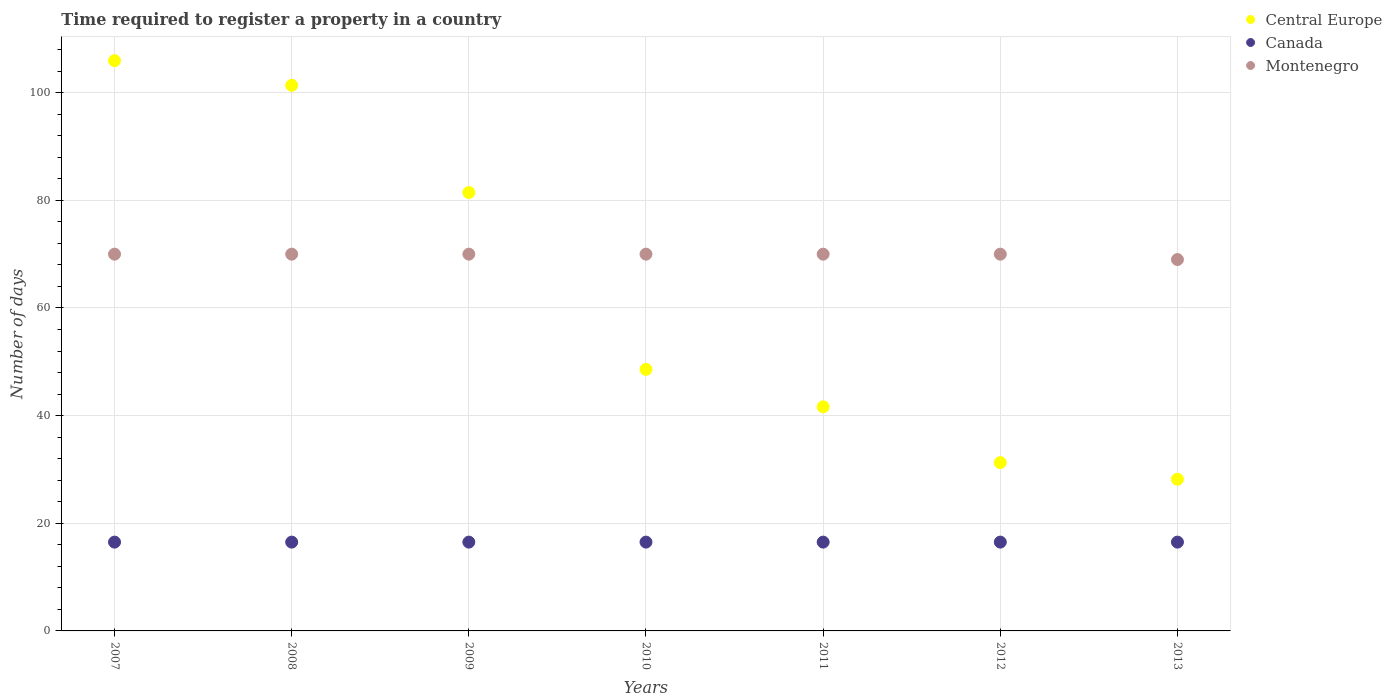How many different coloured dotlines are there?
Your response must be concise. 3. What is the number of days required to register a property in Canada in 2007?
Provide a short and direct response. 16.5. Across all years, what is the maximum number of days required to register a property in Central Europe?
Make the answer very short. 105.95. Across all years, what is the minimum number of days required to register a property in Montenegro?
Provide a succinct answer. 69. In which year was the number of days required to register a property in Montenegro maximum?
Make the answer very short. 2007. In which year was the number of days required to register a property in Canada minimum?
Provide a succinct answer. 2007. What is the total number of days required to register a property in Central Europe in the graph?
Provide a short and direct response. 438.45. What is the difference between the number of days required to register a property in Canada in 2008 and that in 2012?
Keep it short and to the point. 0. What is the difference between the number of days required to register a property in Canada in 2013 and the number of days required to register a property in Central Europe in 2009?
Provide a succinct answer. -64.95. What is the average number of days required to register a property in Montenegro per year?
Your answer should be compact. 69.86. In the year 2007, what is the difference between the number of days required to register a property in Central Europe and number of days required to register a property in Canada?
Your response must be concise. 89.45. In how many years, is the number of days required to register a property in Central Europe greater than 56 days?
Give a very brief answer. 3. What is the ratio of the number of days required to register a property in Montenegro in 2007 to that in 2011?
Your answer should be compact. 1. What is the difference between the highest and the lowest number of days required to register a property in Canada?
Your answer should be very brief. 0. In how many years, is the number of days required to register a property in Canada greater than the average number of days required to register a property in Canada taken over all years?
Provide a succinct answer. 0. Is the sum of the number of days required to register a property in Montenegro in 2011 and 2013 greater than the maximum number of days required to register a property in Central Europe across all years?
Give a very brief answer. Yes. Is it the case that in every year, the sum of the number of days required to register a property in Central Europe and number of days required to register a property in Montenegro  is greater than the number of days required to register a property in Canada?
Give a very brief answer. Yes. Does the number of days required to register a property in Canada monotonically increase over the years?
Offer a very short reply. No. Is the number of days required to register a property in Montenegro strictly greater than the number of days required to register a property in Central Europe over the years?
Ensure brevity in your answer.  No. How many dotlines are there?
Your answer should be compact. 3. How many years are there in the graph?
Keep it short and to the point. 7. What is the difference between two consecutive major ticks on the Y-axis?
Provide a succinct answer. 20. Are the values on the major ticks of Y-axis written in scientific E-notation?
Keep it short and to the point. No. Does the graph contain grids?
Provide a short and direct response. Yes. Where does the legend appear in the graph?
Make the answer very short. Top right. How are the legend labels stacked?
Give a very brief answer. Vertical. What is the title of the graph?
Your answer should be very brief. Time required to register a property in a country. What is the label or title of the Y-axis?
Provide a short and direct response. Number of days. What is the Number of days in Central Europe in 2007?
Your answer should be compact. 105.95. What is the Number of days of Canada in 2007?
Give a very brief answer. 16.5. What is the Number of days in Montenegro in 2007?
Your response must be concise. 70. What is the Number of days in Central Europe in 2008?
Your answer should be very brief. 101.36. What is the Number of days of Central Europe in 2009?
Your answer should be compact. 81.45. What is the Number of days in Canada in 2009?
Your answer should be compact. 16.5. What is the Number of days of Central Europe in 2010?
Provide a short and direct response. 48.59. What is the Number of days of Canada in 2010?
Provide a succinct answer. 16.5. What is the Number of days in Montenegro in 2010?
Your answer should be very brief. 70. What is the Number of days of Central Europe in 2011?
Give a very brief answer. 41.64. What is the Number of days in Canada in 2011?
Provide a succinct answer. 16.5. What is the Number of days in Montenegro in 2011?
Offer a terse response. 70. What is the Number of days of Central Europe in 2012?
Your response must be concise. 31.27. What is the Number of days of Canada in 2012?
Your answer should be compact. 16.5. What is the Number of days in Montenegro in 2012?
Your response must be concise. 70. What is the Number of days of Central Europe in 2013?
Keep it short and to the point. 28.18. What is the Number of days in Canada in 2013?
Your answer should be compact. 16.5. Across all years, what is the maximum Number of days of Central Europe?
Ensure brevity in your answer.  105.95. Across all years, what is the minimum Number of days in Central Europe?
Offer a terse response. 28.18. Across all years, what is the minimum Number of days of Montenegro?
Offer a very short reply. 69. What is the total Number of days in Central Europe in the graph?
Make the answer very short. 438.45. What is the total Number of days of Canada in the graph?
Provide a short and direct response. 115.5. What is the total Number of days of Montenegro in the graph?
Provide a succinct answer. 489. What is the difference between the Number of days in Central Europe in 2007 and that in 2008?
Keep it short and to the point. 4.59. What is the difference between the Number of days in Canada in 2007 and that in 2008?
Your response must be concise. 0. What is the difference between the Number of days of Central Europe in 2007 and that in 2009?
Offer a very short reply. 24.5. What is the difference between the Number of days of Montenegro in 2007 and that in 2009?
Give a very brief answer. 0. What is the difference between the Number of days of Central Europe in 2007 and that in 2010?
Make the answer very short. 57.36. What is the difference between the Number of days of Canada in 2007 and that in 2010?
Ensure brevity in your answer.  0. What is the difference between the Number of days in Montenegro in 2007 and that in 2010?
Provide a short and direct response. 0. What is the difference between the Number of days in Central Europe in 2007 and that in 2011?
Provide a succinct answer. 64.32. What is the difference between the Number of days of Montenegro in 2007 and that in 2011?
Your answer should be compact. 0. What is the difference between the Number of days in Central Europe in 2007 and that in 2012?
Your answer should be very brief. 74.68. What is the difference between the Number of days of Canada in 2007 and that in 2012?
Give a very brief answer. 0. What is the difference between the Number of days in Central Europe in 2007 and that in 2013?
Keep it short and to the point. 77.77. What is the difference between the Number of days of Canada in 2007 and that in 2013?
Give a very brief answer. 0. What is the difference between the Number of days in Montenegro in 2007 and that in 2013?
Provide a succinct answer. 1. What is the difference between the Number of days in Central Europe in 2008 and that in 2009?
Offer a very short reply. 19.91. What is the difference between the Number of days of Montenegro in 2008 and that in 2009?
Your answer should be very brief. 0. What is the difference between the Number of days in Central Europe in 2008 and that in 2010?
Offer a very short reply. 52.77. What is the difference between the Number of days in Central Europe in 2008 and that in 2011?
Make the answer very short. 59.73. What is the difference between the Number of days in Montenegro in 2008 and that in 2011?
Keep it short and to the point. 0. What is the difference between the Number of days of Central Europe in 2008 and that in 2012?
Provide a succinct answer. 70.09. What is the difference between the Number of days in Central Europe in 2008 and that in 2013?
Provide a succinct answer. 73.18. What is the difference between the Number of days in Canada in 2008 and that in 2013?
Keep it short and to the point. 0. What is the difference between the Number of days in Central Europe in 2009 and that in 2010?
Keep it short and to the point. 32.86. What is the difference between the Number of days of Canada in 2009 and that in 2010?
Offer a terse response. 0. What is the difference between the Number of days of Montenegro in 2009 and that in 2010?
Offer a very short reply. 0. What is the difference between the Number of days of Central Europe in 2009 and that in 2011?
Make the answer very short. 39.82. What is the difference between the Number of days in Canada in 2009 and that in 2011?
Your response must be concise. 0. What is the difference between the Number of days of Montenegro in 2009 and that in 2011?
Offer a terse response. 0. What is the difference between the Number of days of Central Europe in 2009 and that in 2012?
Offer a very short reply. 50.18. What is the difference between the Number of days of Montenegro in 2009 and that in 2012?
Your answer should be compact. 0. What is the difference between the Number of days of Central Europe in 2009 and that in 2013?
Keep it short and to the point. 53.27. What is the difference between the Number of days of Canada in 2009 and that in 2013?
Ensure brevity in your answer.  0. What is the difference between the Number of days in Montenegro in 2009 and that in 2013?
Keep it short and to the point. 1. What is the difference between the Number of days in Central Europe in 2010 and that in 2011?
Provide a short and direct response. 6.95. What is the difference between the Number of days in Central Europe in 2010 and that in 2012?
Ensure brevity in your answer.  17.32. What is the difference between the Number of days in Central Europe in 2010 and that in 2013?
Offer a terse response. 20.41. What is the difference between the Number of days in Central Europe in 2011 and that in 2012?
Provide a short and direct response. 10.36. What is the difference between the Number of days in Canada in 2011 and that in 2012?
Ensure brevity in your answer.  0. What is the difference between the Number of days in Montenegro in 2011 and that in 2012?
Offer a very short reply. 0. What is the difference between the Number of days in Central Europe in 2011 and that in 2013?
Offer a terse response. 13.45. What is the difference between the Number of days in Canada in 2011 and that in 2013?
Make the answer very short. 0. What is the difference between the Number of days of Montenegro in 2011 and that in 2013?
Your response must be concise. 1. What is the difference between the Number of days of Central Europe in 2012 and that in 2013?
Keep it short and to the point. 3.09. What is the difference between the Number of days of Canada in 2012 and that in 2013?
Give a very brief answer. 0. What is the difference between the Number of days of Central Europe in 2007 and the Number of days of Canada in 2008?
Give a very brief answer. 89.45. What is the difference between the Number of days of Central Europe in 2007 and the Number of days of Montenegro in 2008?
Ensure brevity in your answer.  35.95. What is the difference between the Number of days of Canada in 2007 and the Number of days of Montenegro in 2008?
Your response must be concise. -53.5. What is the difference between the Number of days of Central Europe in 2007 and the Number of days of Canada in 2009?
Your answer should be very brief. 89.45. What is the difference between the Number of days in Central Europe in 2007 and the Number of days in Montenegro in 2009?
Ensure brevity in your answer.  35.95. What is the difference between the Number of days in Canada in 2007 and the Number of days in Montenegro in 2009?
Keep it short and to the point. -53.5. What is the difference between the Number of days in Central Europe in 2007 and the Number of days in Canada in 2010?
Provide a short and direct response. 89.45. What is the difference between the Number of days of Central Europe in 2007 and the Number of days of Montenegro in 2010?
Offer a very short reply. 35.95. What is the difference between the Number of days in Canada in 2007 and the Number of days in Montenegro in 2010?
Keep it short and to the point. -53.5. What is the difference between the Number of days of Central Europe in 2007 and the Number of days of Canada in 2011?
Provide a succinct answer. 89.45. What is the difference between the Number of days of Central Europe in 2007 and the Number of days of Montenegro in 2011?
Give a very brief answer. 35.95. What is the difference between the Number of days of Canada in 2007 and the Number of days of Montenegro in 2011?
Provide a succinct answer. -53.5. What is the difference between the Number of days in Central Europe in 2007 and the Number of days in Canada in 2012?
Your answer should be very brief. 89.45. What is the difference between the Number of days of Central Europe in 2007 and the Number of days of Montenegro in 2012?
Your response must be concise. 35.95. What is the difference between the Number of days of Canada in 2007 and the Number of days of Montenegro in 2012?
Offer a very short reply. -53.5. What is the difference between the Number of days of Central Europe in 2007 and the Number of days of Canada in 2013?
Provide a short and direct response. 89.45. What is the difference between the Number of days in Central Europe in 2007 and the Number of days in Montenegro in 2013?
Ensure brevity in your answer.  36.95. What is the difference between the Number of days of Canada in 2007 and the Number of days of Montenegro in 2013?
Provide a succinct answer. -52.5. What is the difference between the Number of days of Central Europe in 2008 and the Number of days of Canada in 2009?
Make the answer very short. 84.86. What is the difference between the Number of days of Central Europe in 2008 and the Number of days of Montenegro in 2009?
Offer a terse response. 31.36. What is the difference between the Number of days of Canada in 2008 and the Number of days of Montenegro in 2009?
Ensure brevity in your answer.  -53.5. What is the difference between the Number of days of Central Europe in 2008 and the Number of days of Canada in 2010?
Ensure brevity in your answer.  84.86. What is the difference between the Number of days of Central Europe in 2008 and the Number of days of Montenegro in 2010?
Provide a succinct answer. 31.36. What is the difference between the Number of days in Canada in 2008 and the Number of days in Montenegro in 2010?
Make the answer very short. -53.5. What is the difference between the Number of days in Central Europe in 2008 and the Number of days in Canada in 2011?
Your response must be concise. 84.86. What is the difference between the Number of days of Central Europe in 2008 and the Number of days of Montenegro in 2011?
Your answer should be compact. 31.36. What is the difference between the Number of days in Canada in 2008 and the Number of days in Montenegro in 2011?
Ensure brevity in your answer.  -53.5. What is the difference between the Number of days of Central Europe in 2008 and the Number of days of Canada in 2012?
Make the answer very short. 84.86. What is the difference between the Number of days of Central Europe in 2008 and the Number of days of Montenegro in 2012?
Your answer should be very brief. 31.36. What is the difference between the Number of days of Canada in 2008 and the Number of days of Montenegro in 2012?
Offer a terse response. -53.5. What is the difference between the Number of days in Central Europe in 2008 and the Number of days in Canada in 2013?
Your answer should be compact. 84.86. What is the difference between the Number of days of Central Europe in 2008 and the Number of days of Montenegro in 2013?
Make the answer very short. 32.36. What is the difference between the Number of days in Canada in 2008 and the Number of days in Montenegro in 2013?
Offer a terse response. -52.5. What is the difference between the Number of days in Central Europe in 2009 and the Number of days in Canada in 2010?
Make the answer very short. 64.95. What is the difference between the Number of days of Central Europe in 2009 and the Number of days of Montenegro in 2010?
Keep it short and to the point. 11.45. What is the difference between the Number of days in Canada in 2009 and the Number of days in Montenegro in 2010?
Provide a short and direct response. -53.5. What is the difference between the Number of days of Central Europe in 2009 and the Number of days of Canada in 2011?
Your answer should be compact. 64.95. What is the difference between the Number of days of Central Europe in 2009 and the Number of days of Montenegro in 2011?
Give a very brief answer. 11.45. What is the difference between the Number of days in Canada in 2009 and the Number of days in Montenegro in 2011?
Your response must be concise. -53.5. What is the difference between the Number of days in Central Europe in 2009 and the Number of days in Canada in 2012?
Ensure brevity in your answer.  64.95. What is the difference between the Number of days in Central Europe in 2009 and the Number of days in Montenegro in 2012?
Make the answer very short. 11.45. What is the difference between the Number of days of Canada in 2009 and the Number of days of Montenegro in 2012?
Keep it short and to the point. -53.5. What is the difference between the Number of days in Central Europe in 2009 and the Number of days in Canada in 2013?
Give a very brief answer. 64.95. What is the difference between the Number of days in Central Europe in 2009 and the Number of days in Montenegro in 2013?
Offer a very short reply. 12.45. What is the difference between the Number of days of Canada in 2009 and the Number of days of Montenegro in 2013?
Your answer should be compact. -52.5. What is the difference between the Number of days in Central Europe in 2010 and the Number of days in Canada in 2011?
Offer a very short reply. 32.09. What is the difference between the Number of days of Central Europe in 2010 and the Number of days of Montenegro in 2011?
Ensure brevity in your answer.  -21.41. What is the difference between the Number of days in Canada in 2010 and the Number of days in Montenegro in 2011?
Your answer should be compact. -53.5. What is the difference between the Number of days of Central Europe in 2010 and the Number of days of Canada in 2012?
Your answer should be very brief. 32.09. What is the difference between the Number of days in Central Europe in 2010 and the Number of days in Montenegro in 2012?
Make the answer very short. -21.41. What is the difference between the Number of days in Canada in 2010 and the Number of days in Montenegro in 2012?
Your answer should be very brief. -53.5. What is the difference between the Number of days of Central Europe in 2010 and the Number of days of Canada in 2013?
Provide a succinct answer. 32.09. What is the difference between the Number of days of Central Europe in 2010 and the Number of days of Montenegro in 2013?
Your answer should be compact. -20.41. What is the difference between the Number of days in Canada in 2010 and the Number of days in Montenegro in 2013?
Offer a very short reply. -52.5. What is the difference between the Number of days of Central Europe in 2011 and the Number of days of Canada in 2012?
Keep it short and to the point. 25.14. What is the difference between the Number of days in Central Europe in 2011 and the Number of days in Montenegro in 2012?
Provide a succinct answer. -28.36. What is the difference between the Number of days in Canada in 2011 and the Number of days in Montenegro in 2012?
Offer a very short reply. -53.5. What is the difference between the Number of days of Central Europe in 2011 and the Number of days of Canada in 2013?
Offer a very short reply. 25.14. What is the difference between the Number of days of Central Europe in 2011 and the Number of days of Montenegro in 2013?
Your response must be concise. -27.36. What is the difference between the Number of days of Canada in 2011 and the Number of days of Montenegro in 2013?
Your answer should be very brief. -52.5. What is the difference between the Number of days in Central Europe in 2012 and the Number of days in Canada in 2013?
Your response must be concise. 14.77. What is the difference between the Number of days of Central Europe in 2012 and the Number of days of Montenegro in 2013?
Provide a short and direct response. -37.73. What is the difference between the Number of days in Canada in 2012 and the Number of days in Montenegro in 2013?
Make the answer very short. -52.5. What is the average Number of days of Central Europe per year?
Make the answer very short. 62.64. What is the average Number of days in Montenegro per year?
Your answer should be compact. 69.86. In the year 2007, what is the difference between the Number of days in Central Europe and Number of days in Canada?
Give a very brief answer. 89.45. In the year 2007, what is the difference between the Number of days in Central Europe and Number of days in Montenegro?
Ensure brevity in your answer.  35.95. In the year 2007, what is the difference between the Number of days of Canada and Number of days of Montenegro?
Give a very brief answer. -53.5. In the year 2008, what is the difference between the Number of days in Central Europe and Number of days in Canada?
Ensure brevity in your answer.  84.86. In the year 2008, what is the difference between the Number of days of Central Europe and Number of days of Montenegro?
Offer a terse response. 31.36. In the year 2008, what is the difference between the Number of days in Canada and Number of days in Montenegro?
Provide a short and direct response. -53.5. In the year 2009, what is the difference between the Number of days in Central Europe and Number of days in Canada?
Offer a very short reply. 64.95. In the year 2009, what is the difference between the Number of days in Central Europe and Number of days in Montenegro?
Give a very brief answer. 11.45. In the year 2009, what is the difference between the Number of days in Canada and Number of days in Montenegro?
Provide a short and direct response. -53.5. In the year 2010, what is the difference between the Number of days in Central Europe and Number of days in Canada?
Ensure brevity in your answer.  32.09. In the year 2010, what is the difference between the Number of days of Central Europe and Number of days of Montenegro?
Provide a succinct answer. -21.41. In the year 2010, what is the difference between the Number of days in Canada and Number of days in Montenegro?
Your response must be concise. -53.5. In the year 2011, what is the difference between the Number of days of Central Europe and Number of days of Canada?
Offer a terse response. 25.14. In the year 2011, what is the difference between the Number of days of Central Europe and Number of days of Montenegro?
Give a very brief answer. -28.36. In the year 2011, what is the difference between the Number of days in Canada and Number of days in Montenegro?
Offer a very short reply. -53.5. In the year 2012, what is the difference between the Number of days of Central Europe and Number of days of Canada?
Ensure brevity in your answer.  14.77. In the year 2012, what is the difference between the Number of days of Central Europe and Number of days of Montenegro?
Keep it short and to the point. -38.73. In the year 2012, what is the difference between the Number of days in Canada and Number of days in Montenegro?
Your answer should be very brief. -53.5. In the year 2013, what is the difference between the Number of days in Central Europe and Number of days in Canada?
Your answer should be very brief. 11.68. In the year 2013, what is the difference between the Number of days of Central Europe and Number of days of Montenegro?
Give a very brief answer. -40.82. In the year 2013, what is the difference between the Number of days of Canada and Number of days of Montenegro?
Provide a succinct answer. -52.5. What is the ratio of the Number of days of Central Europe in 2007 to that in 2008?
Make the answer very short. 1.05. What is the ratio of the Number of days in Canada in 2007 to that in 2008?
Give a very brief answer. 1. What is the ratio of the Number of days in Montenegro in 2007 to that in 2008?
Your answer should be compact. 1. What is the ratio of the Number of days of Central Europe in 2007 to that in 2009?
Provide a short and direct response. 1.3. What is the ratio of the Number of days of Canada in 2007 to that in 2009?
Provide a succinct answer. 1. What is the ratio of the Number of days of Montenegro in 2007 to that in 2009?
Your answer should be compact. 1. What is the ratio of the Number of days in Central Europe in 2007 to that in 2010?
Provide a short and direct response. 2.18. What is the ratio of the Number of days in Montenegro in 2007 to that in 2010?
Offer a very short reply. 1. What is the ratio of the Number of days in Central Europe in 2007 to that in 2011?
Give a very brief answer. 2.54. What is the ratio of the Number of days of Central Europe in 2007 to that in 2012?
Give a very brief answer. 3.39. What is the ratio of the Number of days of Canada in 2007 to that in 2012?
Ensure brevity in your answer.  1. What is the ratio of the Number of days in Central Europe in 2007 to that in 2013?
Your answer should be compact. 3.76. What is the ratio of the Number of days of Montenegro in 2007 to that in 2013?
Make the answer very short. 1.01. What is the ratio of the Number of days in Central Europe in 2008 to that in 2009?
Offer a terse response. 1.24. What is the ratio of the Number of days in Canada in 2008 to that in 2009?
Your answer should be very brief. 1. What is the ratio of the Number of days in Montenegro in 2008 to that in 2009?
Your response must be concise. 1. What is the ratio of the Number of days of Central Europe in 2008 to that in 2010?
Ensure brevity in your answer.  2.09. What is the ratio of the Number of days of Montenegro in 2008 to that in 2010?
Your answer should be compact. 1. What is the ratio of the Number of days of Central Europe in 2008 to that in 2011?
Offer a terse response. 2.43. What is the ratio of the Number of days of Canada in 2008 to that in 2011?
Offer a very short reply. 1. What is the ratio of the Number of days in Central Europe in 2008 to that in 2012?
Provide a succinct answer. 3.24. What is the ratio of the Number of days in Canada in 2008 to that in 2012?
Offer a very short reply. 1. What is the ratio of the Number of days of Montenegro in 2008 to that in 2012?
Ensure brevity in your answer.  1. What is the ratio of the Number of days of Central Europe in 2008 to that in 2013?
Make the answer very short. 3.6. What is the ratio of the Number of days of Canada in 2008 to that in 2013?
Provide a short and direct response. 1. What is the ratio of the Number of days of Montenegro in 2008 to that in 2013?
Offer a terse response. 1.01. What is the ratio of the Number of days in Central Europe in 2009 to that in 2010?
Provide a succinct answer. 1.68. What is the ratio of the Number of days of Montenegro in 2009 to that in 2010?
Offer a terse response. 1. What is the ratio of the Number of days of Central Europe in 2009 to that in 2011?
Provide a short and direct response. 1.96. What is the ratio of the Number of days of Canada in 2009 to that in 2011?
Give a very brief answer. 1. What is the ratio of the Number of days of Central Europe in 2009 to that in 2012?
Your answer should be compact. 2.6. What is the ratio of the Number of days of Central Europe in 2009 to that in 2013?
Your answer should be very brief. 2.89. What is the ratio of the Number of days of Canada in 2009 to that in 2013?
Make the answer very short. 1. What is the ratio of the Number of days in Montenegro in 2009 to that in 2013?
Provide a short and direct response. 1.01. What is the ratio of the Number of days in Central Europe in 2010 to that in 2011?
Provide a succinct answer. 1.17. What is the ratio of the Number of days in Canada in 2010 to that in 2011?
Offer a very short reply. 1. What is the ratio of the Number of days of Central Europe in 2010 to that in 2012?
Your answer should be compact. 1.55. What is the ratio of the Number of days in Central Europe in 2010 to that in 2013?
Offer a very short reply. 1.72. What is the ratio of the Number of days of Montenegro in 2010 to that in 2013?
Your answer should be compact. 1.01. What is the ratio of the Number of days of Central Europe in 2011 to that in 2012?
Provide a succinct answer. 1.33. What is the ratio of the Number of days in Central Europe in 2011 to that in 2013?
Provide a short and direct response. 1.48. What is the ratio of the Number of days in Canada in 2011 to that in 2013?
Your answer should be compact. 1. What is the ratio of the Number of days in Montenegro in 2011 to that in 2013?
Provide a succinct answer. 1.01. What is the ratio of the Number of days of Central Europe in 2012 to that in 2013?
Offer a very short reply. 1.11. What is the ratio of the Number of days in Canada in 2012 to that in 2013?
Your answer should be very brief. 1. What is the ratio of the Number of days in Montenegro in 2012 to that in 2013?
Offer a very short reply. 1.01. What is the difference between the highest and the second highest Number of days of Central Europe?
Ensure brevity in your answer.  4.59. What is the difference between the highest and the second highest Number of days of Montenegro?
Offer a terse response. 0. What is the difference between the highest and the lowest Number of days of Central Europe?
Provide a short and direct response. 77.77. 